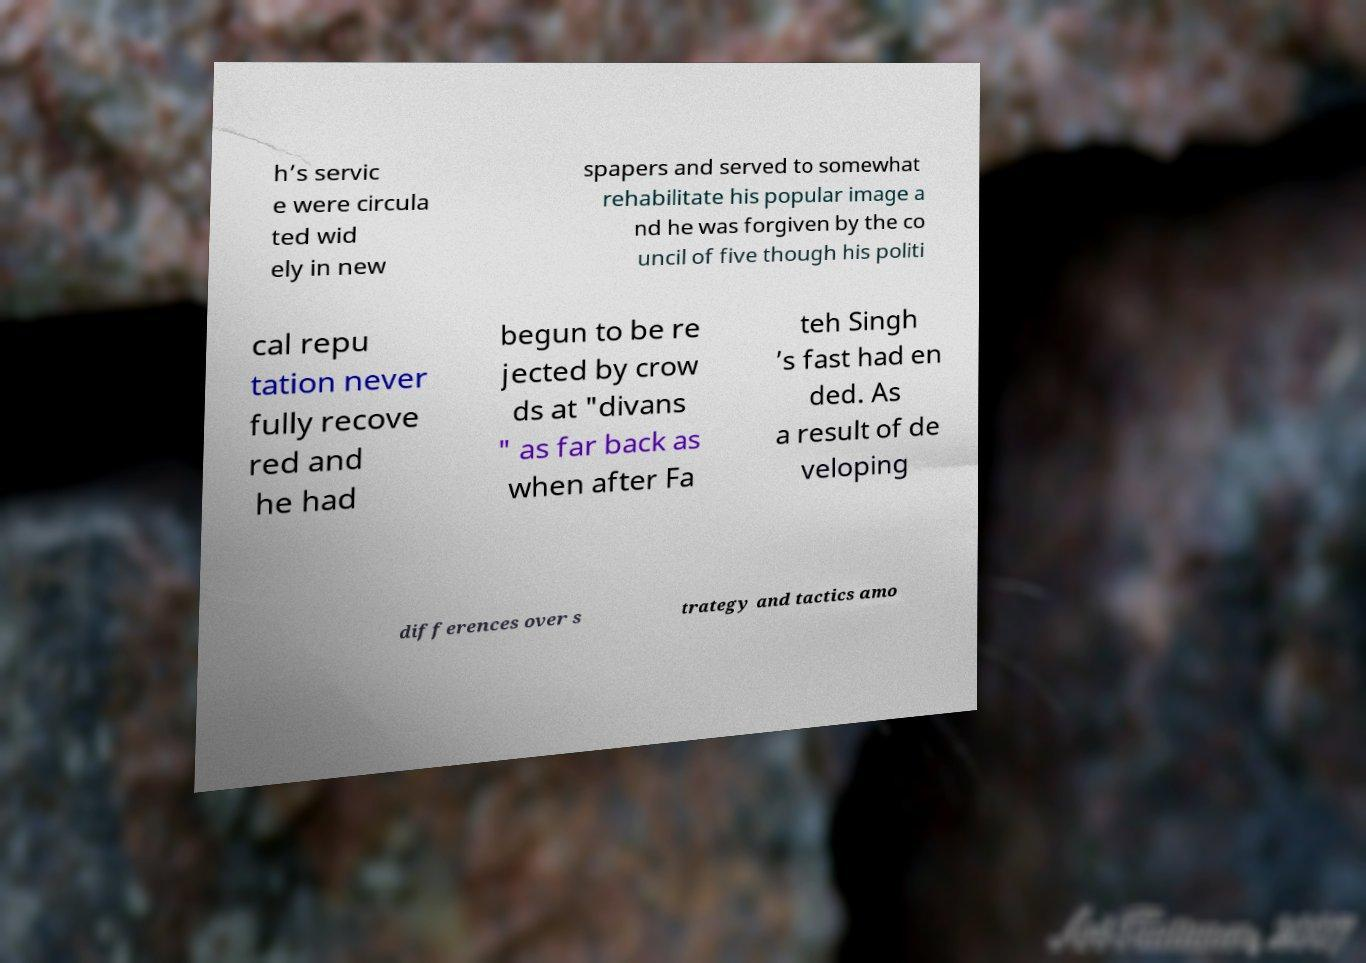What messages or text are displayed in this image? I need them in a readable, typed format. h’s servic e were circula ted wid ely in new spapers and served to somewhat rehabilitate his popular image a nd he was forgiven by the co uncil of five though his politi cal repu tation never fully recove red and he had begun to be re jected by crow ds at "divans " as far back as when after Fa teh Singh ’s fast had en ded. As a result of de veloping differences over s trategy and tactics amo 